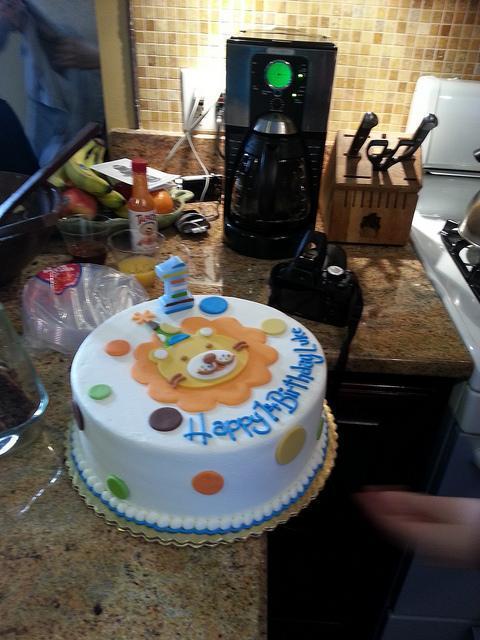How many beds are in this room?
Give a very brief answer. 0. 